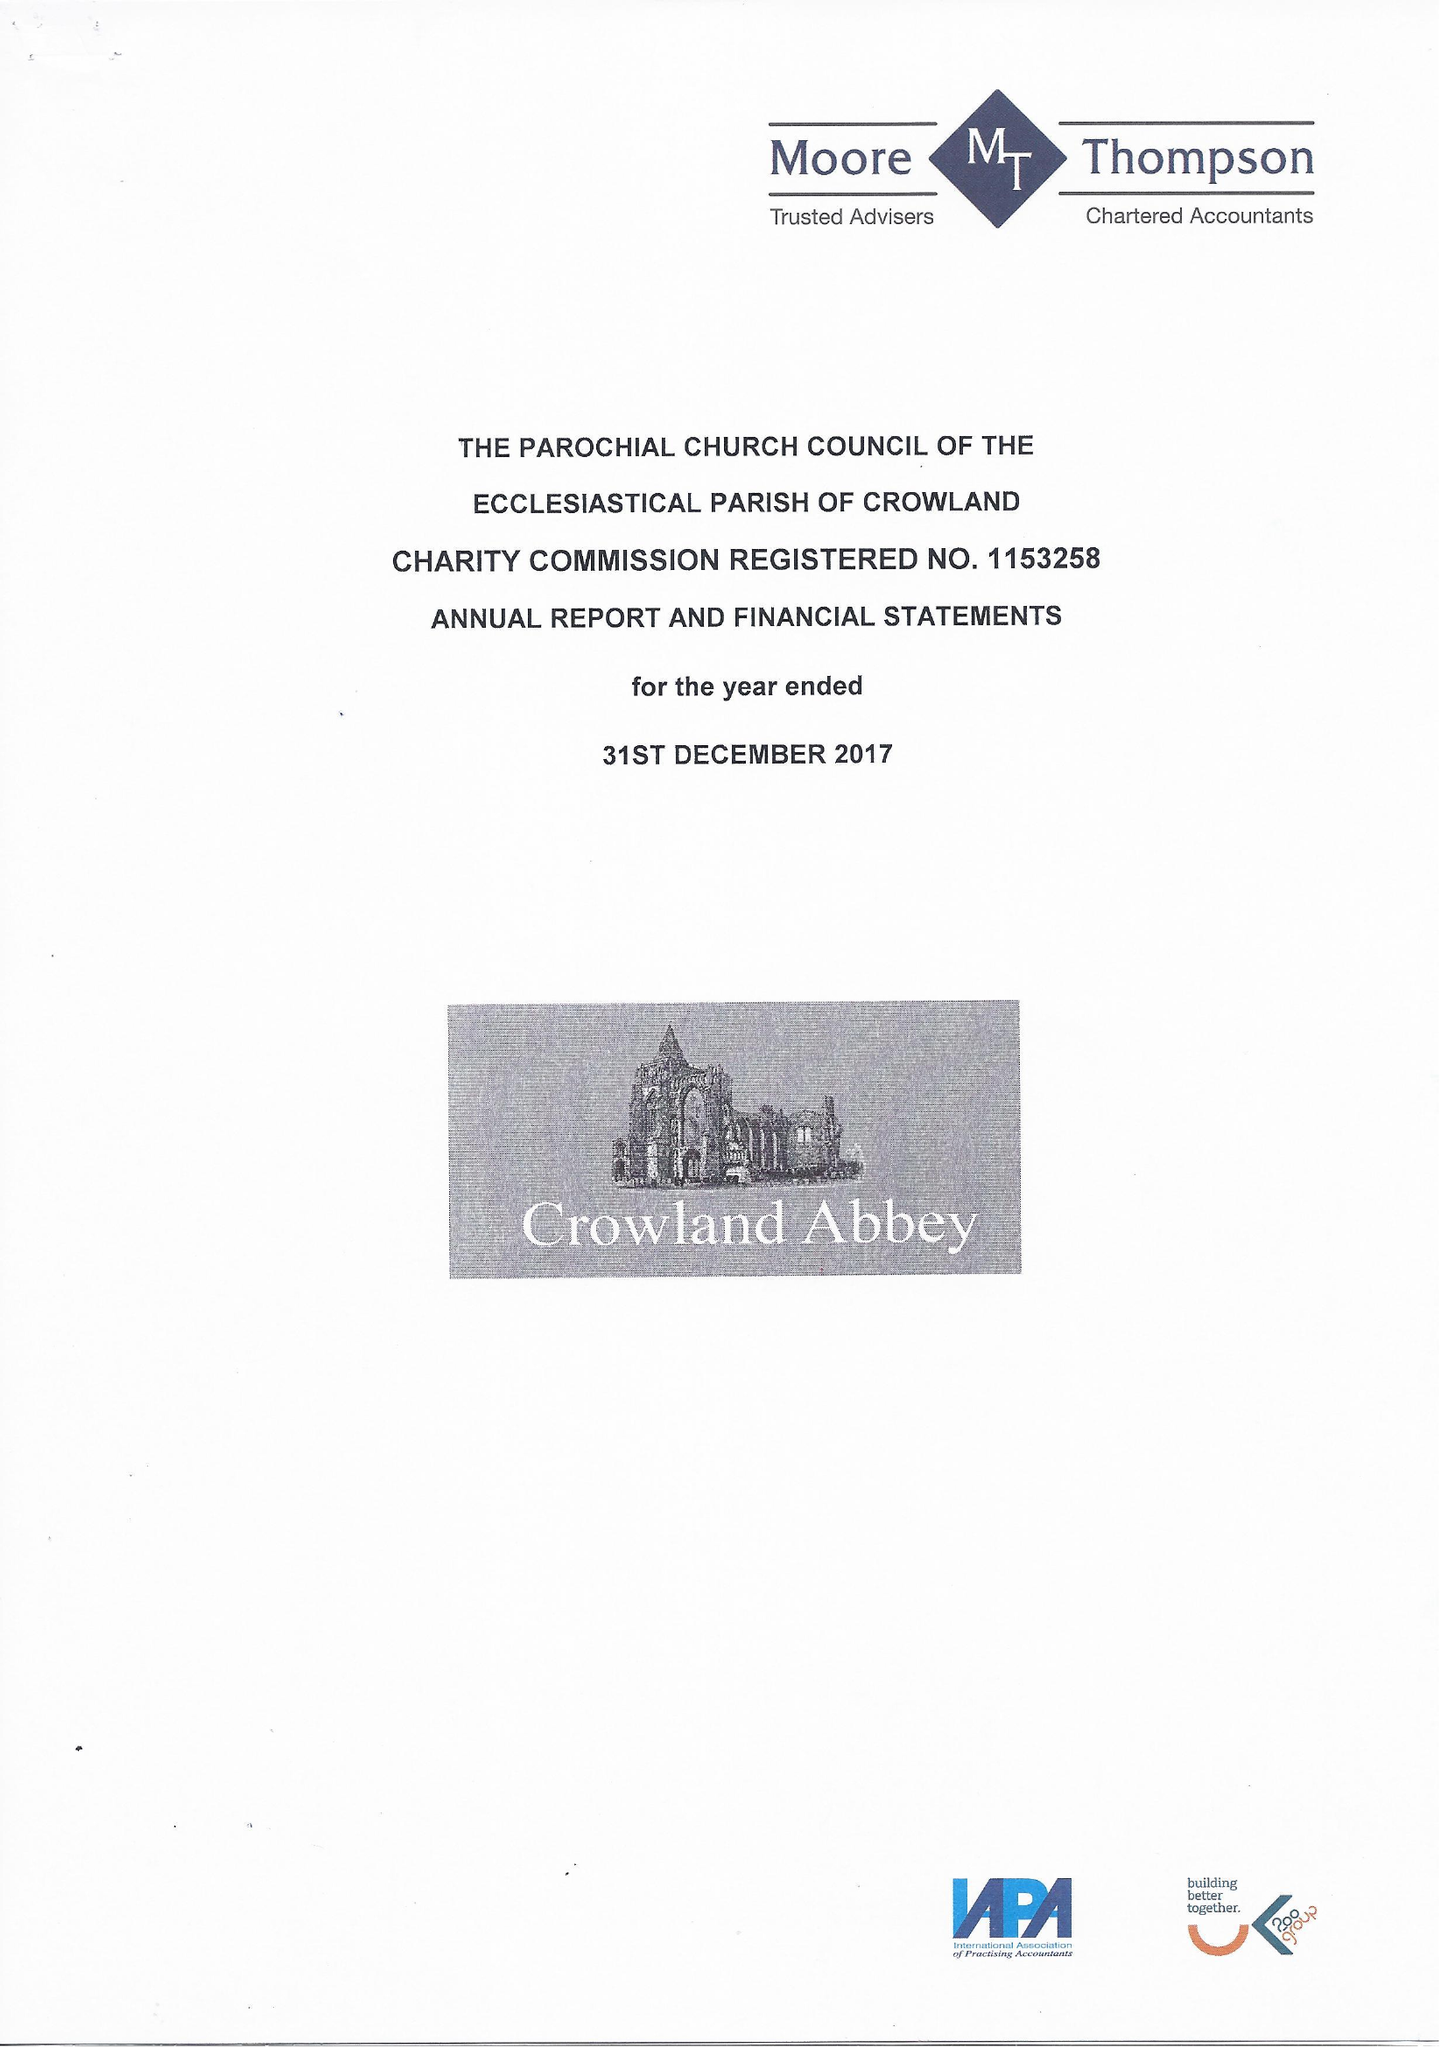What is the value for the address__street_line?
Answer the question using a single word or phrase. 3 PENWALD CLOSE 